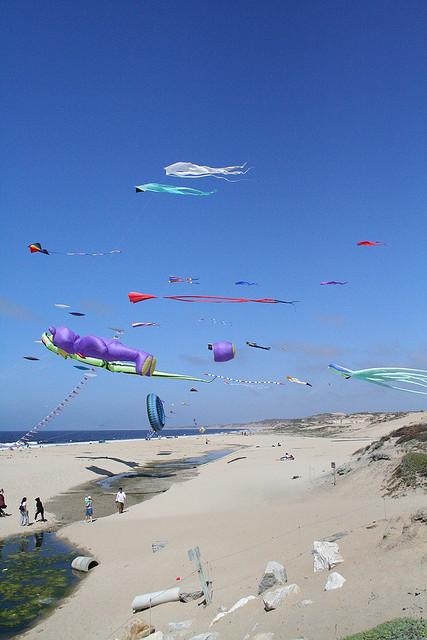What direction is the wind blowing? Please explain your reasoning. right. All of the kites are headed to the right. 